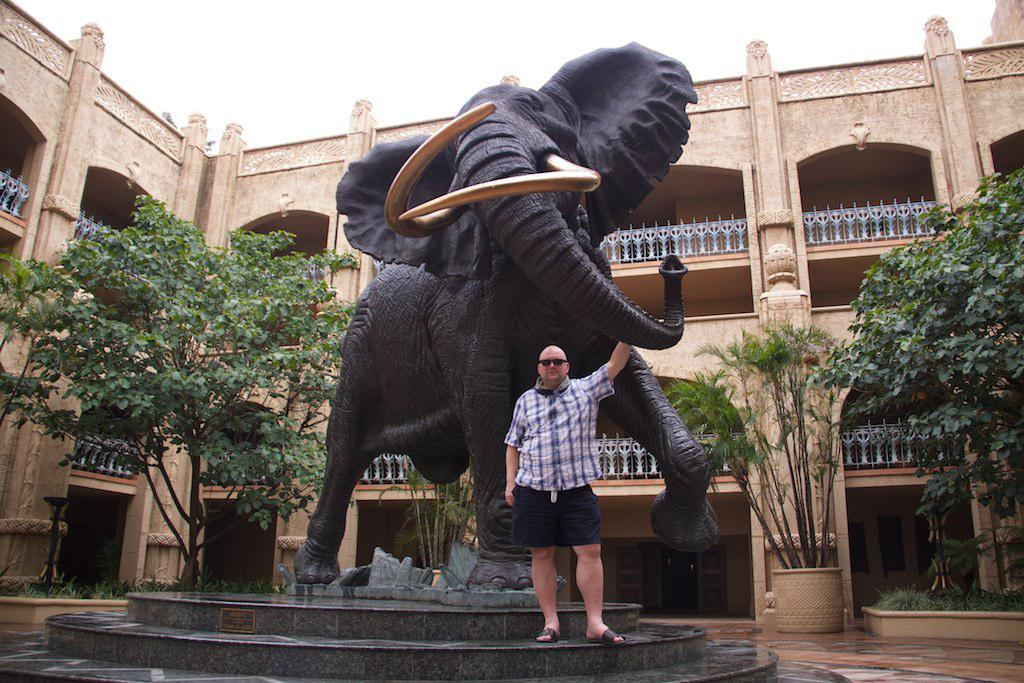What is the main subject of the image? There is a person standing in the center of the image. What can be seen in the background of the image? There is an elephant statue, a building, and trees in the background of the image. What type of substance is the person holding in the image? There is no substance visible in the person's hand in the image. What kind of cup can be seen near the elephant statue in the image? There is no cup present near the elephant statue in the image. 